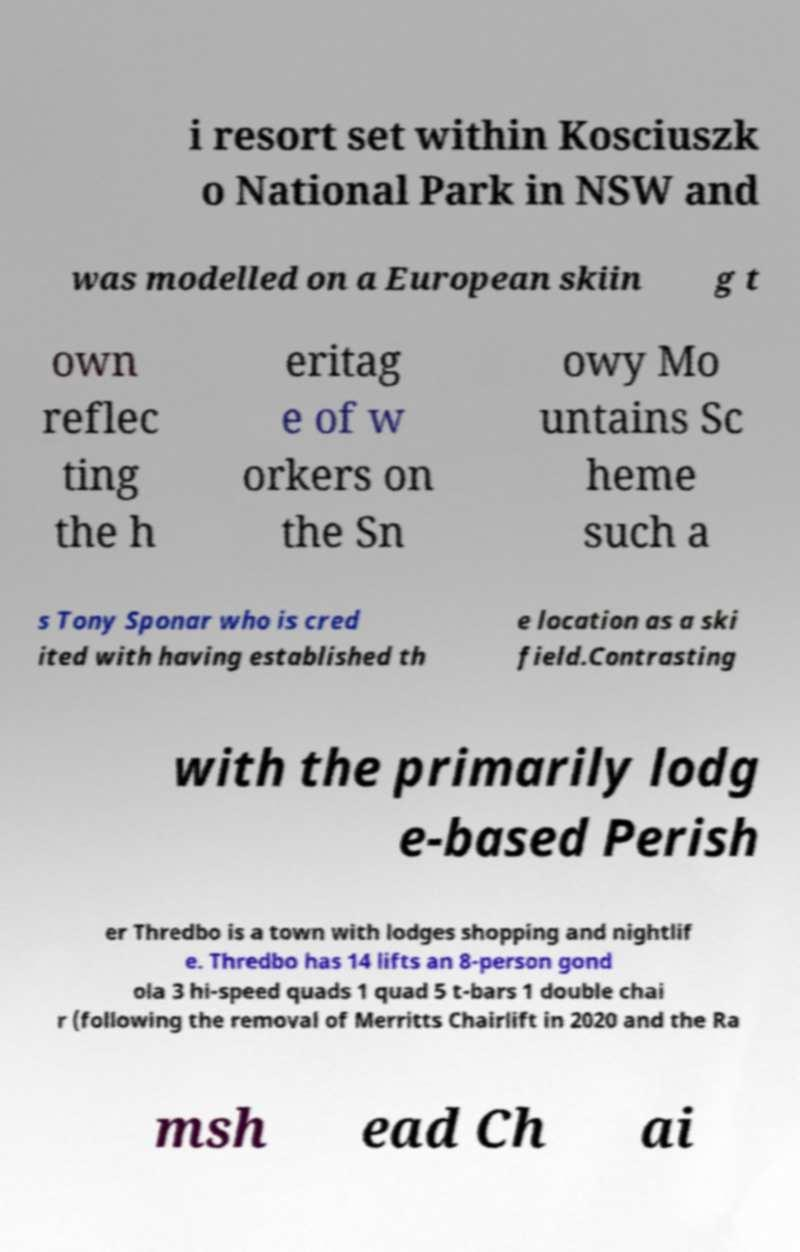Could you assist in decoding the text presented in this image and type it out clearly? i resort set within Kosciuszk o National Park in NSW and was modelled on a European skiin g t own reflec ting the h eritag e of w orkers on the Sn owy Mo untains Sc heme such a s Tony Sponar who is cred ited with having established th e location as a ski field.Contrasting with the primarily lodg e-based Perish er Thredbo is a town with lodges shopping and nightlif e. Thredbo has 14 lifts an 8-person gond ola 3 hi-speed quads 1 quad 5 t-bars 1 double chai r (following the removal of Merritts Chairlift in 2020 and the Ra msh ead Ch ai 